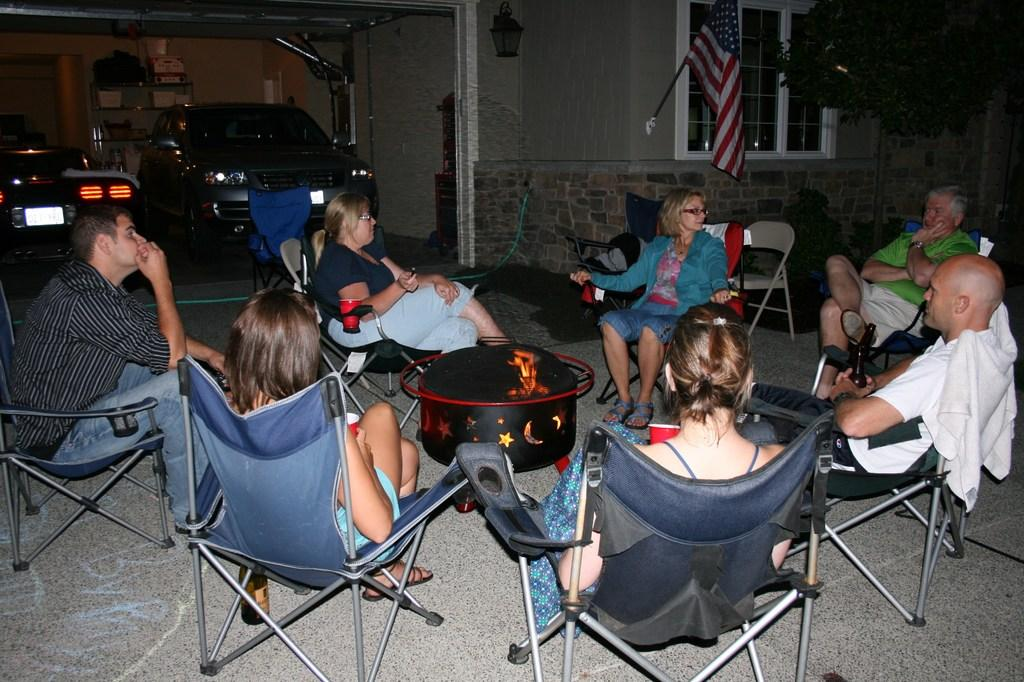How many people are in the group visible in the image? There is a group of people in the image, but the exact number is not specified. What are the people in the group doing? The group of people are sitting around a black box. What is inside the black box? The black box has fire in it. What can be seen in the background of the image? There are cars, a flag, and a building in the background of the image. What type of spoon is being used by the zebra in the image? There is no zebra present in the image, and therefore no spoon can be associated with it. 